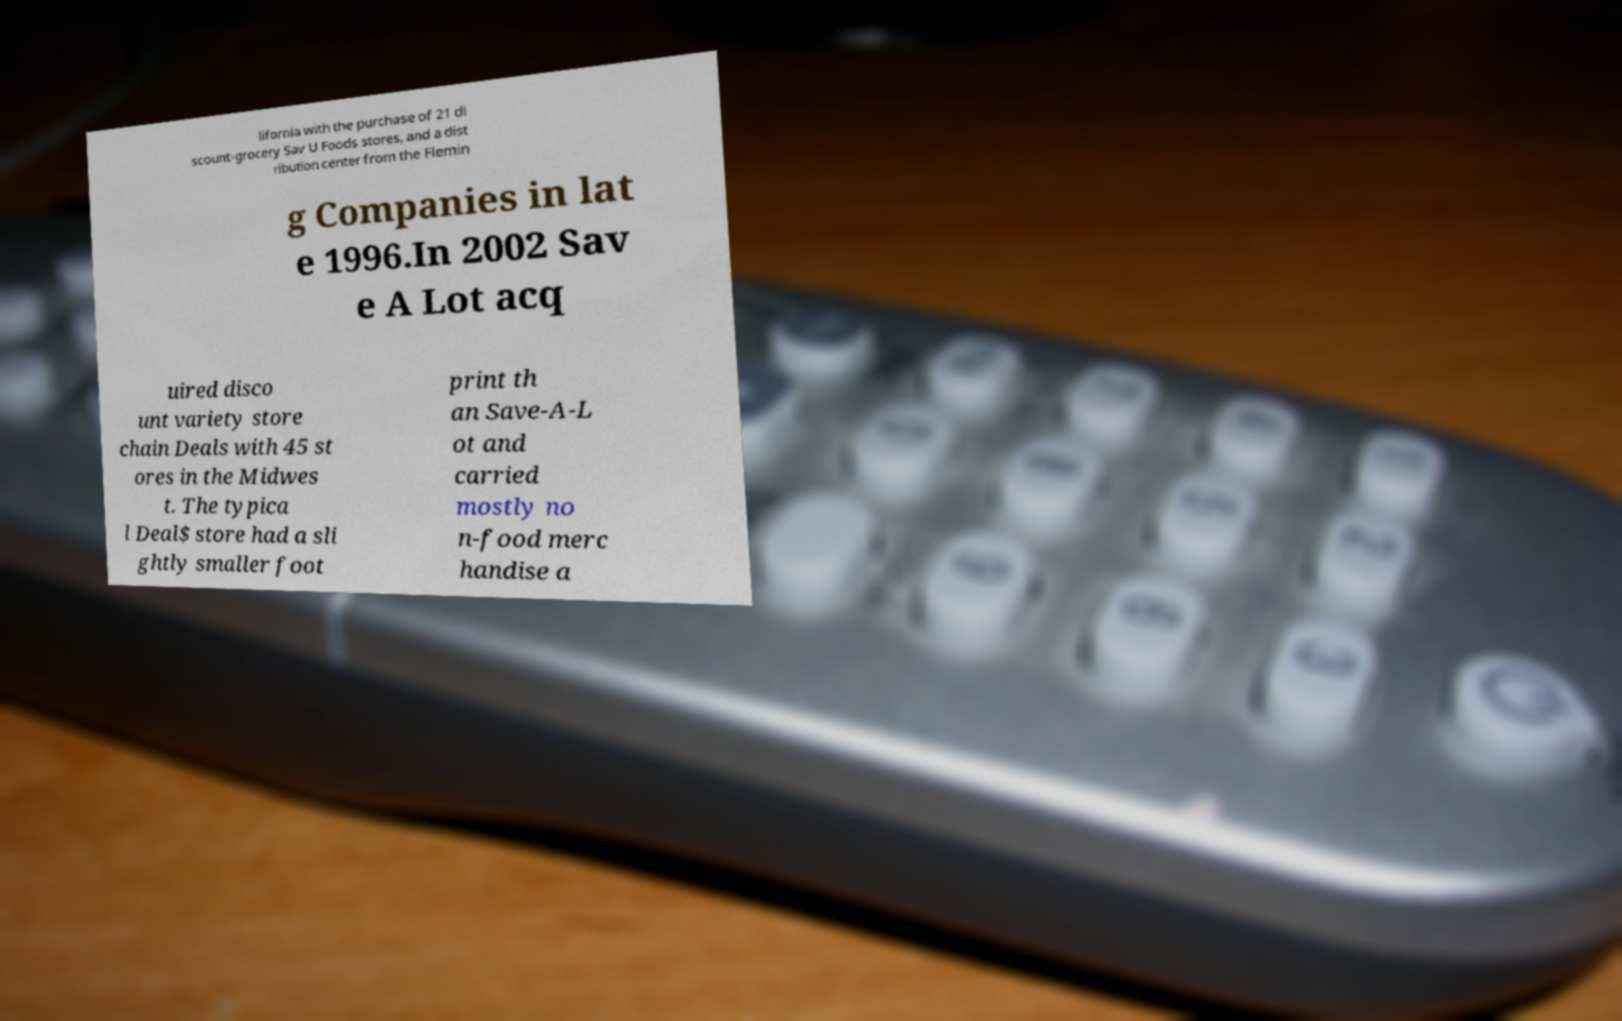For documentation purposes, I need the text within this image transcribed. Could you provide that? lifornia with the purchase of 21 di scount-grocery Sav U Foods stores, and a dist ribution center from the Flemin g Companies in lat e 1996.In 2002 Sav e A Lot acq uired disco unt variety store chain Deals with 45 st ores in the Midwes t. The typica l Deal$ store had a sli ghtly smaller foot print th an Save-A-L ot and carried mostly no n-food merc handise a 